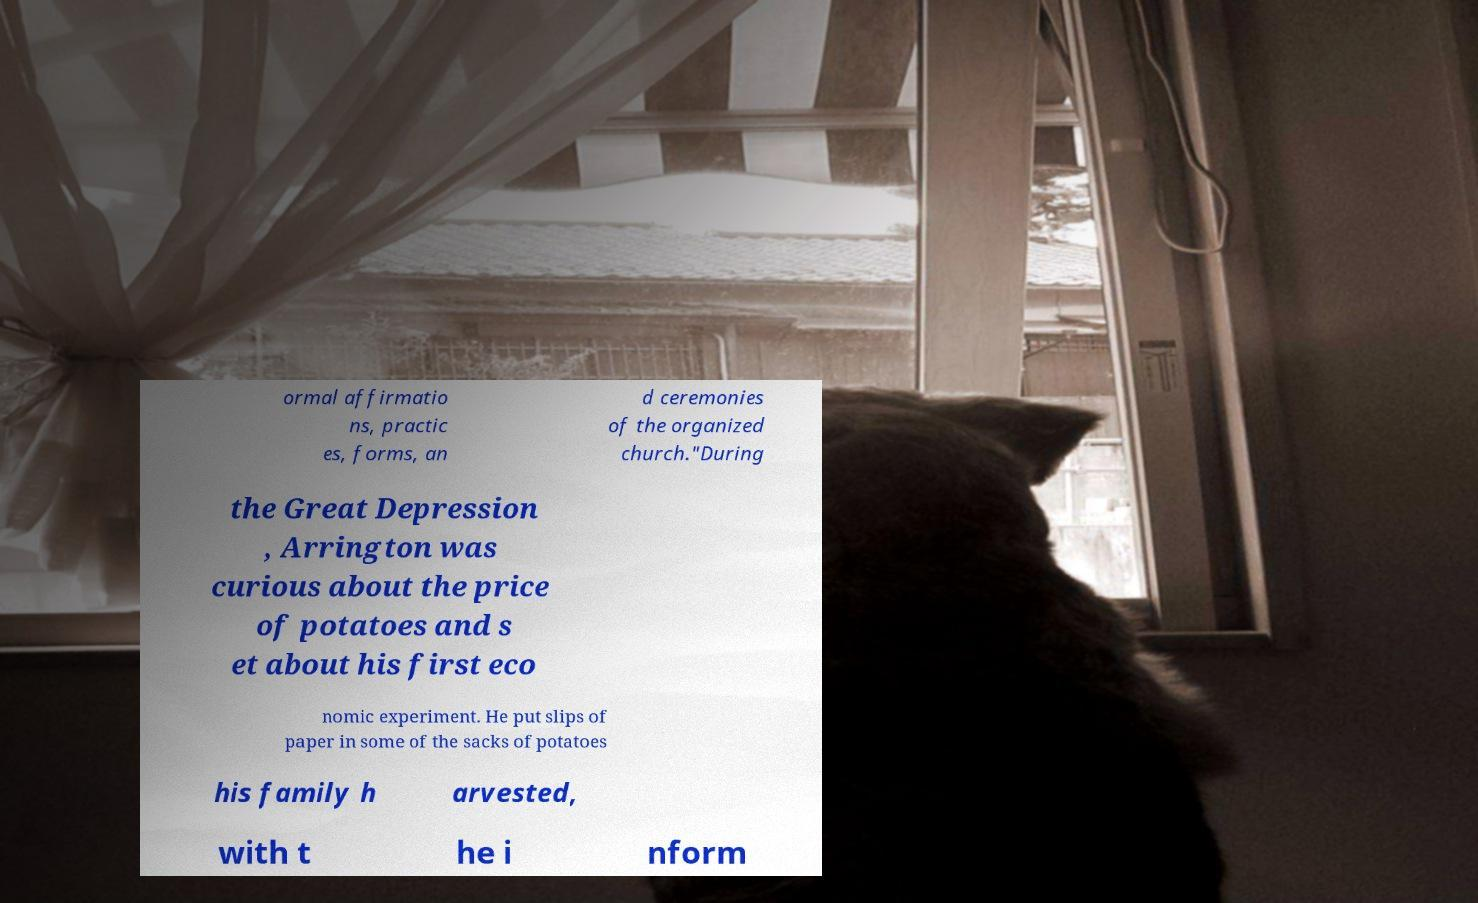For documentation purposes, I need the text within this image transcribed. Could you provide that? ormal affirmatio ns, practic es, forms, an d ceremonies of the organized church."During the Great Depression , Arrington was curious about the price of potatoes and s et about his first eco nomic experiment. He put slips of paper in some of the sacks of potatoes his family h arvested, with t he i nform 